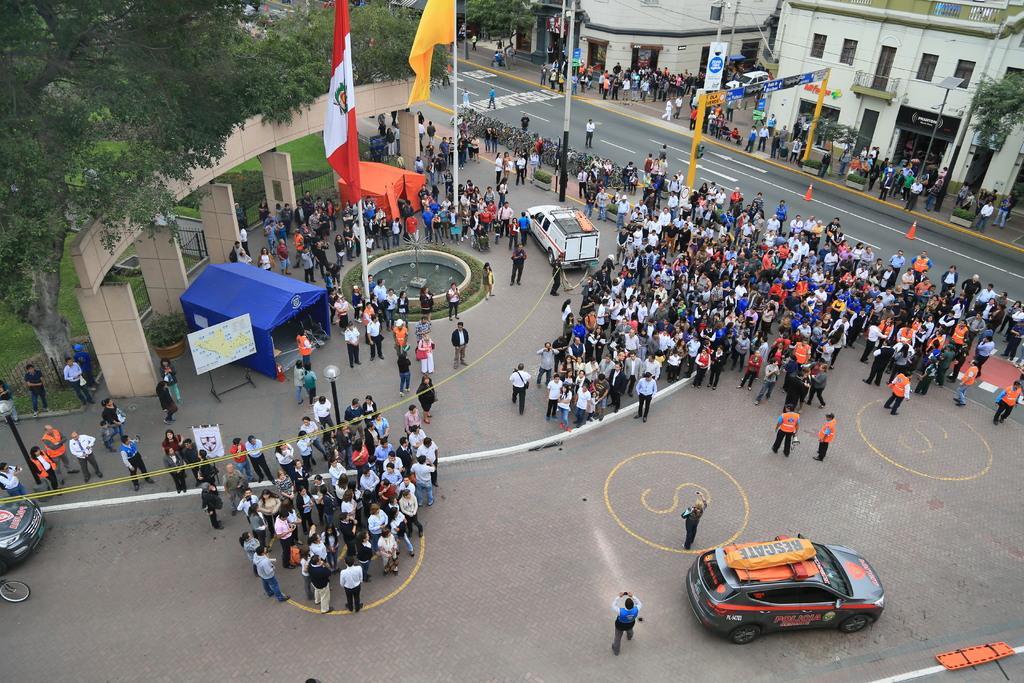Describe this image in one or two sentences. In this picture we can see a group of people, vehicles on the ground, here we can see sheds, flags, traffic cones, electric poles, pillars, name board, poster and some objects and in the background we can see buildings, trees. 